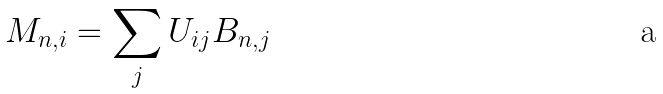Convert formula to latex. <formula><loc_0><loc_0><loc_500><loc_500>M _ { n , i } = \sum _ { j } U _ { i j } B _ { n , j }</formula> 